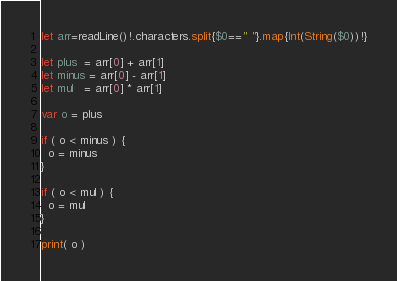<code> <loc_0><loc_0><loc_500><loc_500><_Swift_>let arr=readLine()!.characters.split{$0==" "}.map{Int(String($0))!}

let plus  = arr[0] + arr[1]
let minus = arr[0] - arr[1]
let mul   = arr[0] * arr[1]

var o = plus

if ( o < minus ) {
  o = minus
}

if ( o < mul ) {
  o = mul
}

print( o )
</code> 